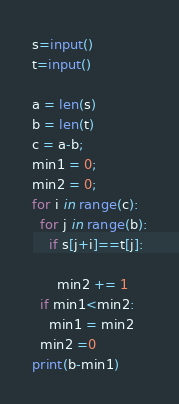<code> <loc_0><loc_0><loc_500><loc_500><_Python_>s=input()
t=input()

a = len(s)
b = len(t)
c = a-b;
min1 = 0;
min2 = 0;
for i in range(c):
  for j in range(b):
    if s[j+i]==t[j]:
      
      min2 += 1
  if min1<min2:
    min1 = min2
  min2 =0
print(b-min1)</code> 